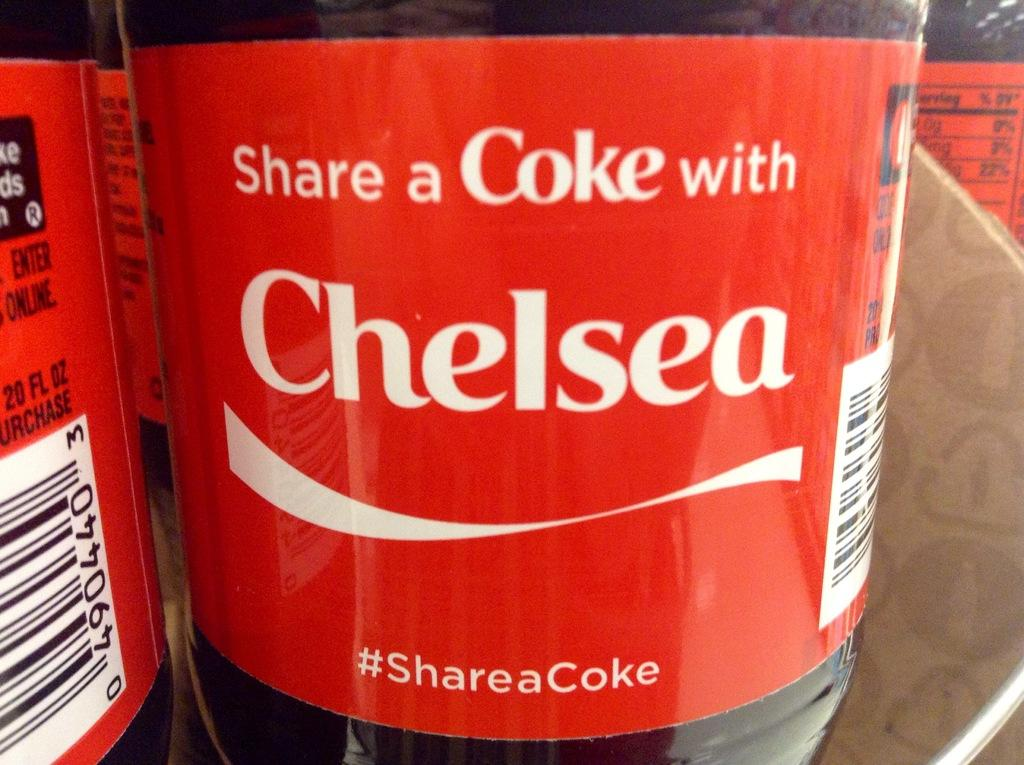What objects are present in the image? There are bottles in the image. How might the bottles be organized in the image? The bottles might be kept in racks. Where might the image have been taken? The image might have been taken in a shop. How many cherries can be seen on the owl in the image? There is no owl or cherry present in the image; it only features bottles. 